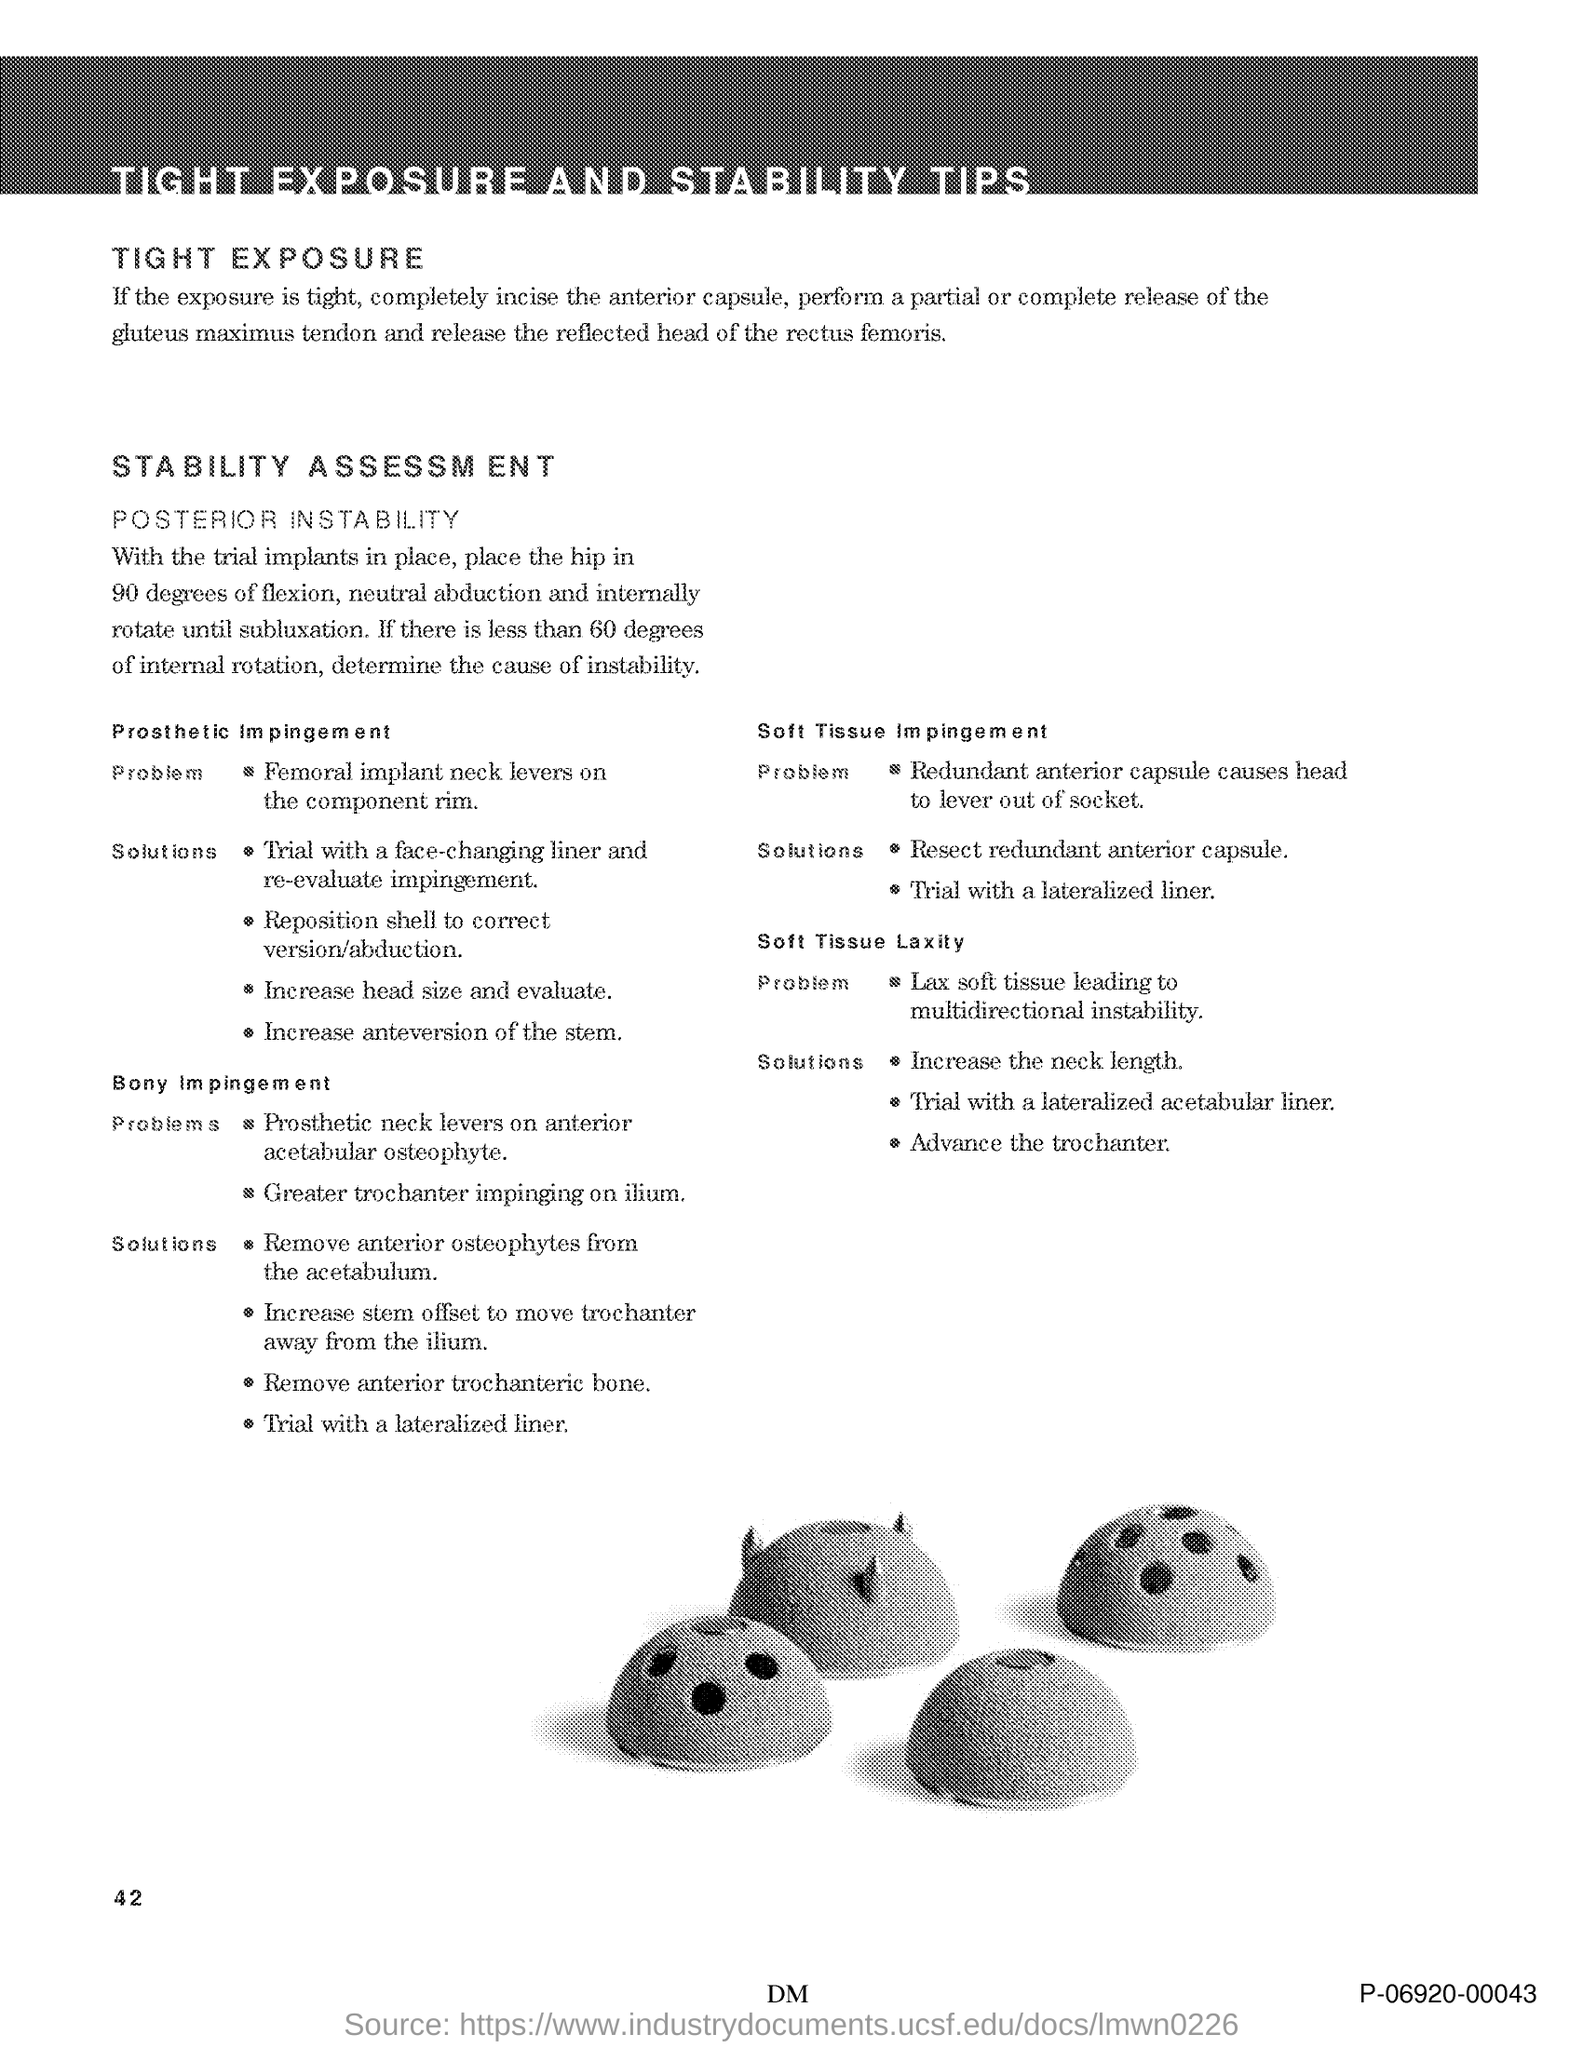What is the title of the document?
Your response must be concise. Tight Exposure and Stability Tips. What is the Page Number?
Your response must be concise. 42. 